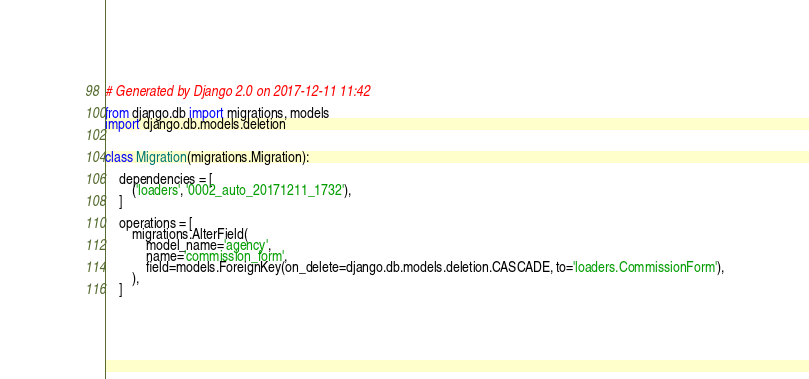Convert code to text. <code><loc_0><loc_0><loc_500><loc_500><_Python_># Generated by Django 2.0 on 2017-12-11 11:42

from django.db import migrations, models
import django.db.models.deletion


class Migration(migrations.Migration):

    dependencies = [
        ('loaders', '0002_auto_20171211_1732'),
    ]

    operations = [
        migrations.AlterField(
            model_name='agency',
            name='commission_form',
            field=models.ForeignKey(on_delete=django.db.models.deletion.CASCADE, to='loaders.CommissionForm'),
        ),
    ]
</code> 